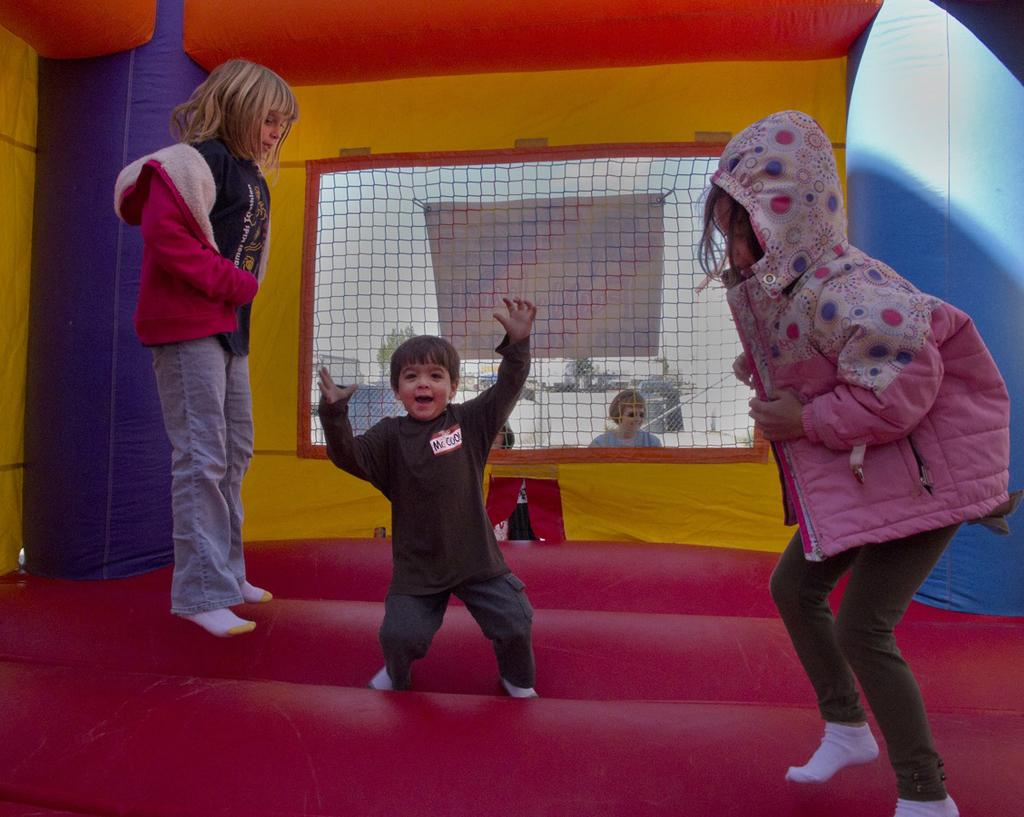Who is present in the image? There are children in the image. What are the children doing in the image? The children are in a bounce house. What type of egg is visible in the image? There is no egg present in the image. 